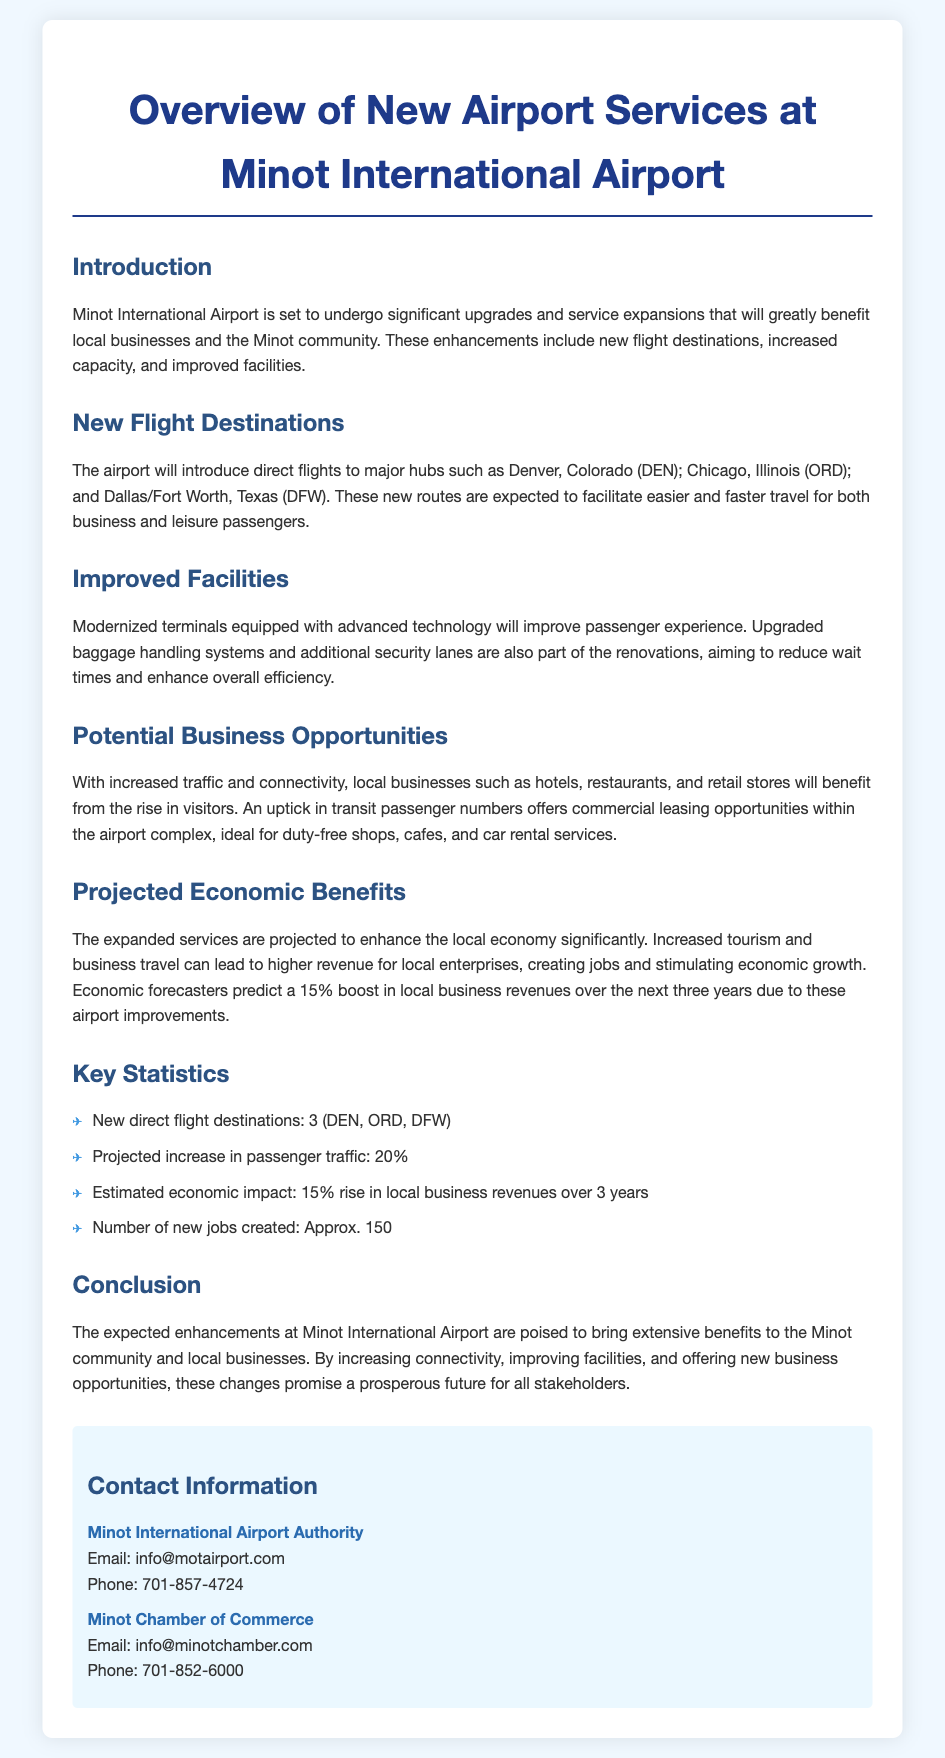What are the new flight destinations? The document lists Denver, Chicago, and Dallas/Fort Worth as the new flight destinations.
Answer: Denver, Chicago, Dallas/Fort Worth What is the projected increase in passenger traffic? The document states that the projected increase in passenger traffic is 20%.
Answer: 20% How many new jobs are expected to be created? The document mentions that approximately 150 new jobs are expected to be created due to the airport improvements.
Answer: Approx. 150 What is the estimated economic impact over the next three years? The document forecasts a 15% rise in local business revenues over the next three years as a result of the airport changes.
Answer: 15% What type of businesses may benefit from increased traffic? Local businesses such as hotels, restaurants, and retail stores are identified as benefitting from increased traffic.
Answer: Hotels, restaurants, retail stores Which airport authority can be contacted for more information? The Minot International Airport Authority is provided as a contact for more information.
Answer: Minot International Airport Authority How many new direct flight destinations will there be? According to the document, there will be three new direct flight destinations.
Answer: 3 What is the email address for the Minot Chamber of Commerce? The email address listed for the Minot Chamber of Commerce in the document is info@minotchamber.com.
Answer: info@minotchamber.com 